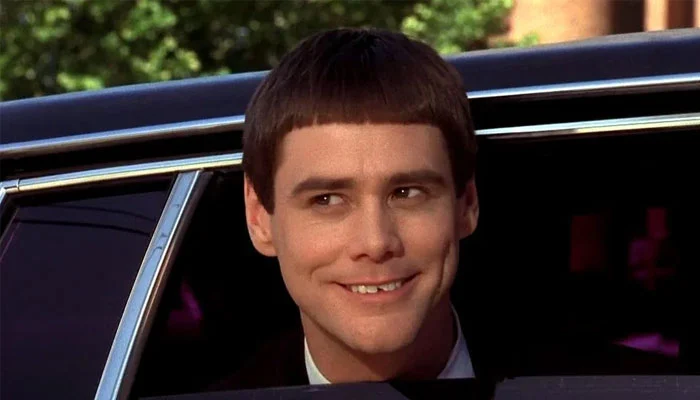Describe the potential events leading up to or following this captured moment. It's conceivable that this image captures a moment of spontaneous joy or celebration. Perhaps the subject was heading to a cheerful social event, or maybe he is simply enjoying a charming ride through a scenic locale. Following this moment, the person could be meeting friends or colleagues, contributing to the day's cheerful vibes. 